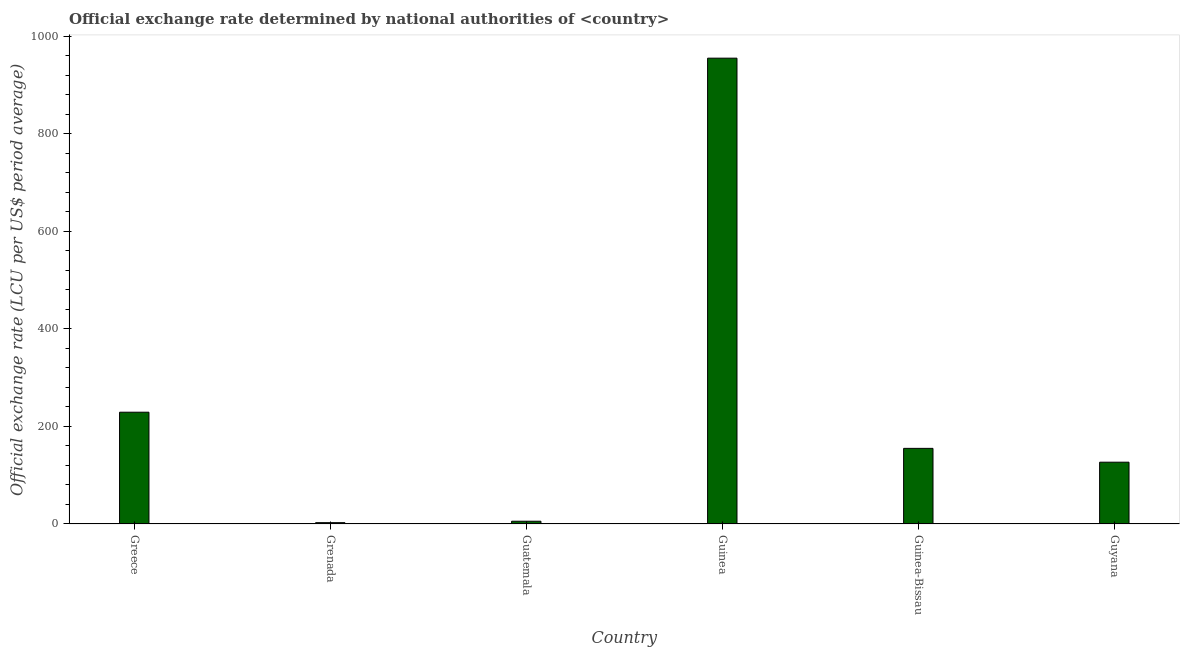Does the graph contain any zero values?
Offer a very short reply. No. Does the graph contain grids?
Provide a short and direct response. No. What is the title of the graph?
Provide a succinct answer. Official exchange rate determined by national authorities of <country>. What is the label or title of the X-axis?
Your answer should be very brief. Country. What is the label or title of the Y-axis?
Offer a terse response. Official exchange rate (LCU per US$ period average). What is the official exchange rate in Guyana?
Offer a terse response. 126.73. Across all countries, what is the maximum official exchange rate?
Offer a very short reply. 955.49. In which country was the official exchange rate maximum?
Your answer should be compact. Guinea. In which country was the official exchange rate minimum?
Your answer should be compact. Grenada. What is the sum of the official exchange rate?
Your answer should be compact. 1474.91. What is the difference between the official exchange rate in Grenada and Guyana?
Keep it short and to the point. -124.03. What is the average official exchange rate per country?
Your response must be concise. 245.82. What is the median official exchange rate?
Your response must be concise. 140.92. In how many countries, is the official exchange rate greater than 680 ?
Your answer should be very brief. 1. What is the ratio of the official exchange rate in Guinea to that in Guinea-Bissau?
Make the answer very short. 6.16. Is the difference between the official exchange rate in Grenada and Guinea-Bissau greater than the difference between any two countries?
Your response must be concise. No. What is the difference between the highest and the second highest official exchange rate?
Make the answer very short. 726.24. What is the difference between the highest and the lowest official exchange rate?
Your response must be concise. 952.79. In how many countries, is the official exchange rate greater than the average official exchange rate taken over all countries?
Your answer should be very brief. 1. How many bars are there?
Provide a succinct answer. 6. Are all the bars in the graph horizontal?
Provide a succinct answer. No. How many countries are there in the graph?
Provide a short and direct response. 6. What is the difference between two consecutive major ticks on the Y-axis?
Ensure brevity in your answer.  200. Are the values on the major ticks of Y-axis written in scientific E-notation?
Provide a succinct answer. No. What is the Official exchange rate (LCU per US$ period average) in Greece?
Make the answer very short. 229.25. What is the Official exchange rate (LCU per US$ period average) of Grenada?
Ensure brevity in your answer.  2.7. What is the Official exchange rate (LCU per US$ period average) in Guatemala?
Offer a very short reply. 5.64. What is the Official exchange rate (LCU per US$ period average) in Guinea?
Keep it short and to the point. 955.49. What is the Official exchange rate (LCU per US$ period average) in Guinea-Bissau?
Offer a very short reply. 155.11. What is the Official exchange rate (LCU per US$ period average) in Guyana?
Ensure brevity in your answer.  126.73. What is the difference between the Official exchange rate (LCU per US$ period average) in Greece and Grenada?
Your response must be concise. 226.55. What is the difference between the Official exchange rate (LCU per US$ period average) in Greece and Guatemala?
Give a very brief answer. 223.61. What is the difference between the Official exchange rate (LCU per US$ period average) in Greece and Guinea?
Offer a terse response. -726.24. What is the difference between the Official exchange rate (LCU per US$ period average) in Greece and Guinea-Bissau?
Give a very brief answer. 74.14. What is the difference between the Official exchange rate (LCU per US$ period average) in Greece and Guyana?
Give a very brief answer. 102.52. What is the difference between the Official exchange rate (LCU per US$ period average) in Grenada and Guatemala?
Your response must be concise. -2.94. What is the difference between the Official exchange rate (LCU per US$ period average) in Grenada and Guinea?
Ensure brevity in your answer.  -952.79. What is the difference between the Official exchange rate (LCU per US$ period average) in Grenada and Guinea-Bissau?
Your answer should be compact. -152.41. What is the difference between the Official exchange rate (LCU per US$ period average) in Grenada and Guyana?
Keep it short and to the point. -124.03. What is the difference between the Official exchange rate (LCU per US$ period average) in Guatemala and Guinea?
Offer a terse response. -949.85. What is the difference between the Official exchange rate (LCU per US$ period average) in Guatemala and Guinea-Bissau?
Keep it short and to the point. -149.47. What is the difference between the Official exchange rate (LCU per US$ period average) in Guatemala and Guyana?
Give a very brief answer. -121.1. What is the difference between the Official exchange rate (LCU per US$ period average) in Guinea and Guinea-Bissau?
Provide a succinct answer. 800.38. What is the difference between the Official exchange rate (LCU per US$ period average) in Guinea and Guyana?
Give a very brief answer. 828.76. What is the difference between the Official exchange rate (LCU per US$ period average) in Guinea-Bissau and Guyana?
Provide a succinct answer. 28.38. What is the ratio of the Official exchange rate (LCU per US$ period average) in Greece to that in Grenada?
Ensure brevity in your answer.  84.91. What is the ratio of the Official exchange rate (LCU per US$ period average) in Greece to that in Guatemala?
Your response must be concise. 40.68. What is the ratio of the Official exchange rate (LCU per US$ period average) in Greece to that in Guinea?
Your answer should be very brief. 0.24. What is the ratio of the Official exchange rate (LCU per US$ period average) in Greece to that in Guinea-Bissau?
Ensure brevity in your answer.  1.48. What is the ratio of the Official exchange rate (LCU per US$ period average) in Greece to that in Guyana?
Provide a short and direct response. 1.81. What is the ratio of the Official exchange rate (LCU per US$ period average) in Grenada to that in Guatemala?
Your answer should be compact. 0.48. What is the ratio of the Official exchange rate (LCU per US$ period average) in Grenada to that in Guinea?
Keep it short and to the point. 0. What is the ratio of the Official exchange rate (LCU per US$ period average) in Grenada to that in Guinea-Bissau?
Your response must be concise. 0.02. What is the ratio of the Official exchange rate (LCU per US$ period average) in Grenada to that in Guyana?
Keep it short and to the point. 0.02. What is the ratio of the Official exchange rate (LCU per US$ period average) in Guatemala to that in Guinea?
Give a very brief answer. 0.01. What is the ratio of the Official exchange rate (LCU per US$ period average) in Guatemala to that in Guinea-Bissau?
Your response must be concise. 0.04. What is the ratio of the Official exchange rate (LCU per US$ period average) in Guatemala to that in Guyana?
Ensure brevity in your answer.  0.04. What is the ratio of the Official exchange rate (LCU per US$ period average) in Guinea to that in Guinea-Bissau?
Ensure brevity in your answer.  6.16. What is the ratio of the Official exchange rate (LCU per US$ period average) in Guinea to that in Guyana?
Your response must be concise. 7.54. What is the ratio of the Official exchange rate (LCU per US$ period average) in Guinea-Bissau to that in Guyana?
Offer a terse response. 1.22. 